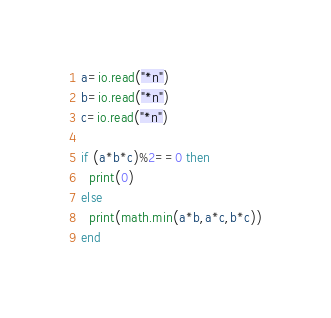Convert code to text. <code><loc_0><loc_0><loc_500><loc_500><_Lua_>a=io.read("*n")
b=io.read("*n")
c=io.read("*n")

if (a*b*c)%2==0 then
  print(0)
else
  print(math.min(a*b,a*c,b*c))
end</code> 